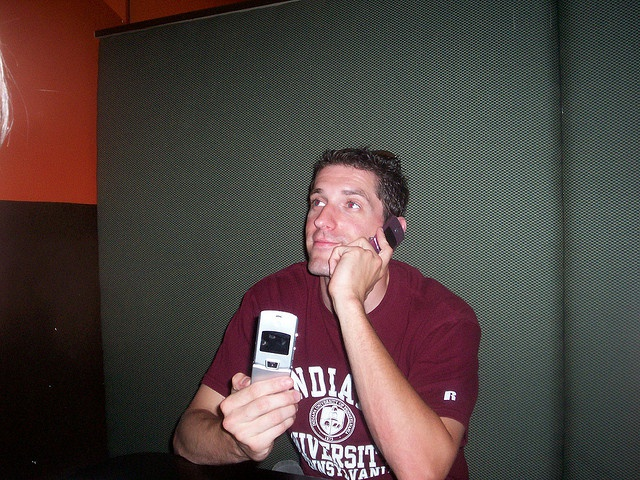Describe the objects in this image and their specific colors. I can see people in maroon, lightpink, lightgray, and black tones, cell phone in maroon, white, black, darkgray, and gray tones, and cell phone in maroon, purple, black, and gray tones in this image. 